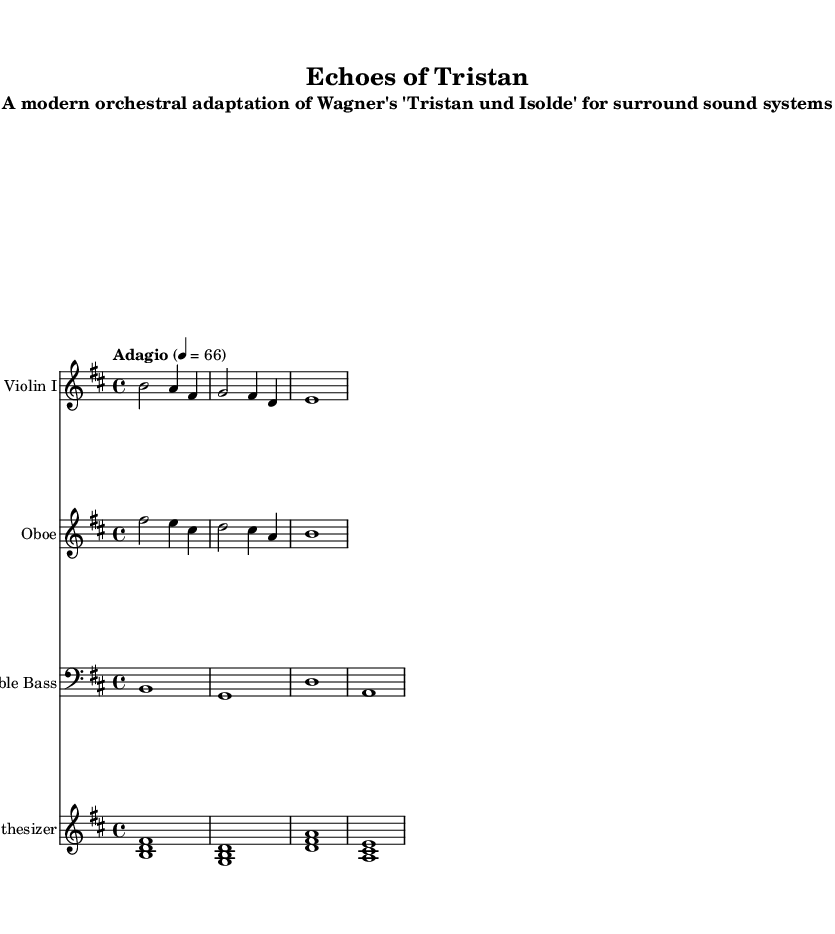What is the key signature of this music? The key signature is indicated at the beginning of the staff, showing two sharps. This corresponds to B minor, where F# and C# are present.
Answer: B minor What is the time signature used in this piece? The time signature is displayed at the beginning of the score, which shows four beats per measure, represented as 4/4.
Answer: 4/4 What is the tempo marking indicated in the score? The tempo marking follows the time signature and specifies "Adagio," which is a slow tempo, along with the beats per minute indicating a speed of 66.
Answer: Adagio How many instruments are featured in this arrangement? The score lists four staves, each representing a different instrument: Violin I, Oboe, Double Bass, and Synthesizer, which means there are four distinct instruments.
Answer: Four What is the highest pitch present in the violin part? Looking at the violin part, the highest note is represented by "b," which can be found in the first measure. It is the highest note in the given music for this instrument.
Answer: B Which instrument plays the lowest note in the score? The lowest note is found in the Double Bass part, where the letter "a" signifies the lowest pitch in the second measure. It is the deepest voice of the arrangement.
Answer: A What is the relationship of the synthesizer chords to the string instruments? The synthesizer plays an integral harmonic role as it provides foundational chords. The chord sequence consists of intervals that enhance the lush texture, complementing the melodies of the Violin and Oboe, thus creating a surround sound experience.
Answer: Harmonic foundation 